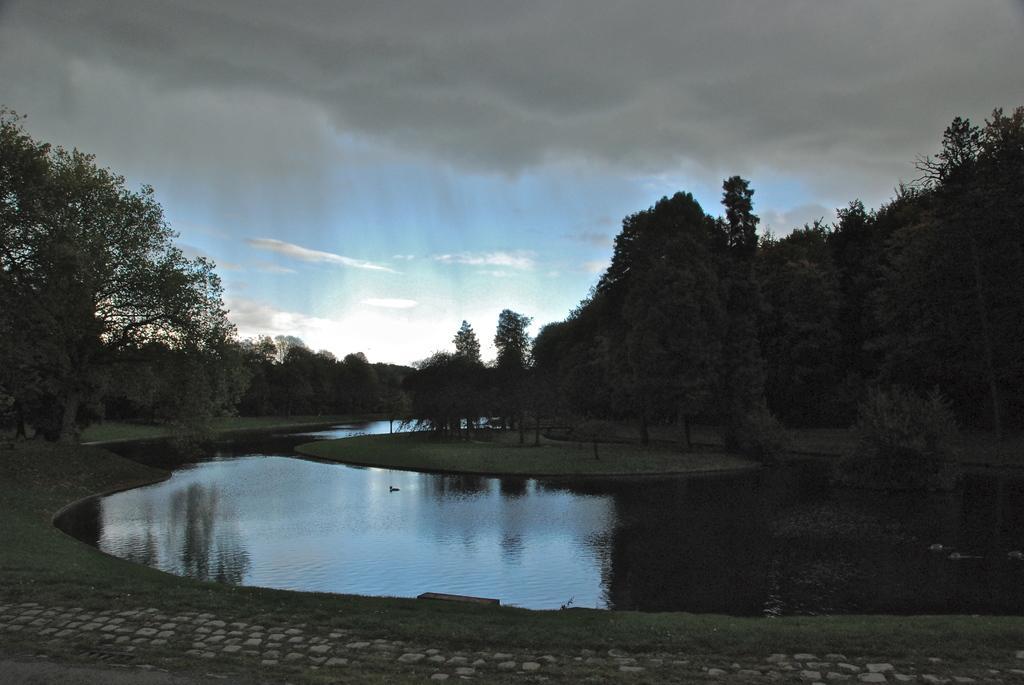Could you give a brief overview of what you see in this image? In this image in the center there is a lake, at the bottom there is a walkway and in the background there are trees and grass. At the top there is sky. 